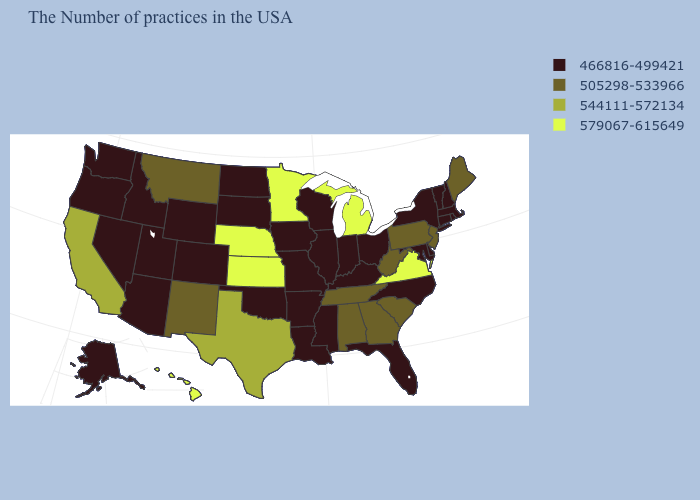What is the value of North Dakota?
Concise answer only. 466816-499421. What is the value of North Dakota?
Quick response, please. 466816-499421. What is the value of South Carolina?
Be succinct. 505298-533966. Among the states that border Utah , which have the lowest value?
Write a very short answer. Wyoming, Colorado, Arizona, Idaho, Nevada. What is the value of Vermont?
Keep it brief. 466816-499421. Does the map have missing data?
Be succinct. No. How many symbols are there in the legend?
Be succinct. 4. What is the value of Florida?
Answer briefly. 466816-499421. Which states have the lowest value in the USA?
Short answer required. Massachusetts, Rhode Island, New Hampshire, Vermont, Connecticut, New York, Delaware, Maryland, North Carolina, Ohio, Florida, Kentucky, Indiana, Wisconsin, Illinois, Mississippi, Louisiana, Missouri, Arkansas, Iowa, Oklahoma, South Dakota, North Dakota, Wyoming, Colorado, Utah, Arizona, Idaho, Nevada, Washington, Oregon, Alaska. Name the states that have a value in the range 544111-572134?
Write a very short answer. Texas, California. Does New Jersey have the same value as West Virginia?
Be succinct. Yes. Name the states that have a value in the range 505298-533966?
Short answer required. Maine, New Jersey, Pennsylvania, South Carolina, West Virginia, Georgia, Alabama, Tennessee, New Mexico, Montana. Does the first symbol in the legend represent the smallest category?
Give a very brief answer. Yes. What is the value of Massachusetts?
Write a very short answer. 466816-499421. Name the states that have a value in the range 544111-572134?
Keep it brief. Texas, California. 